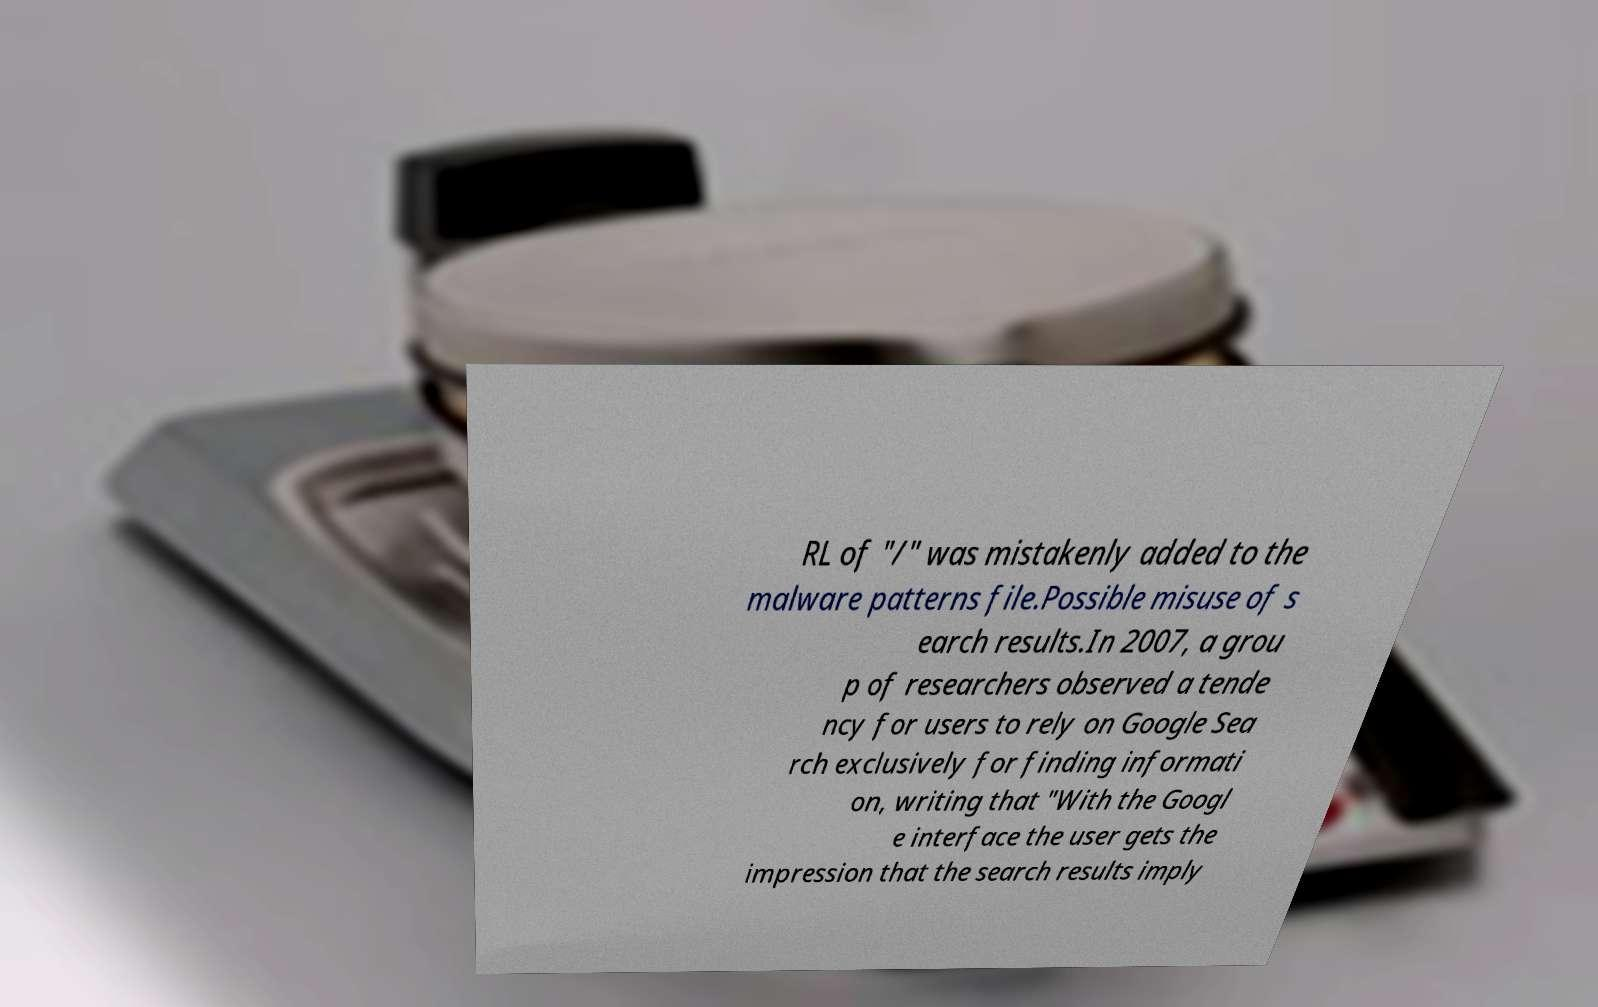Could you assist in decoding the text presented in this image and type it out clearly? RL of "/" was mistakenly added to the malware patterns file.Possible misuse of s earch results.In 2007, a grou p of researchers observed a tende ncy for users to rely on Google Sea rch exclusively for finding informati on, writing that "With the Googl e interface the user gets the impression that the search results imply 